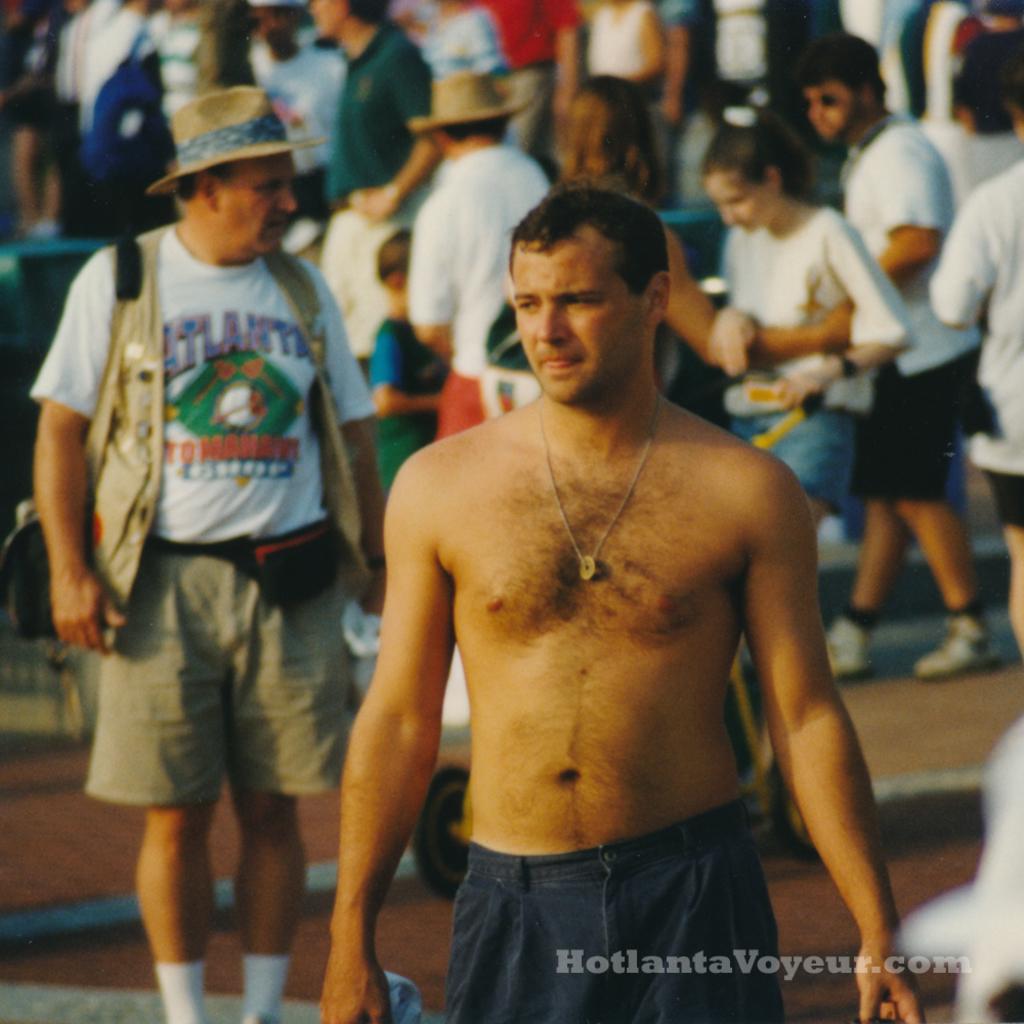Where was this picture taken?
Give a very brief answer. Atlanta. 